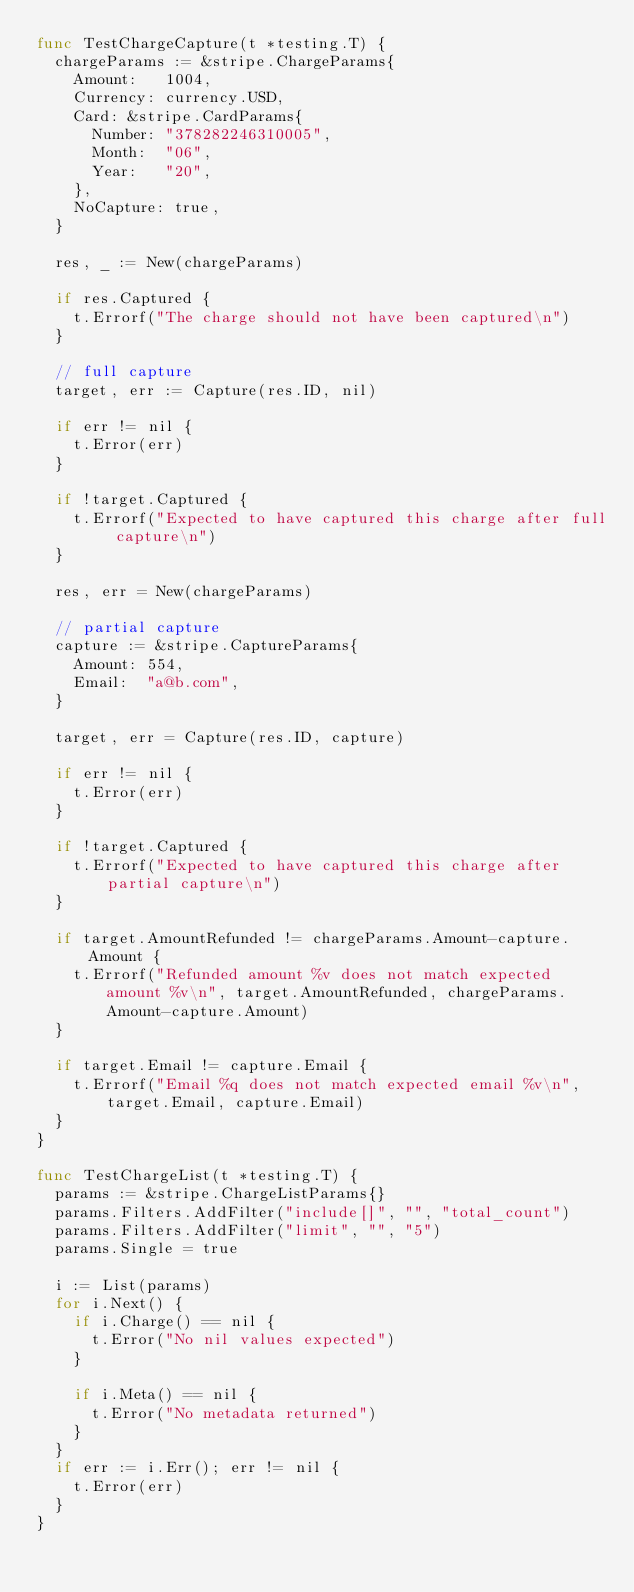<code> <loc_0><loc_0><loc_500><loc_500><_Go_>func TestChargeCapture(t *testing.T) {
	chargeParams := &stripe.ChargeParams{
		Amount:   1004,
		Currency: currency.USD,
		Card: &stripe.CardParams{
			Number: "378282246310005",
			Month:  "06",
			Year:   "20",
		},
		NoCapture: true,
	}

	res, _ := New(chargeParams)

	if res.Captured {
		t.Errorf("The charge should not have been captured\n")
	}

	// full capture
	target, err := Capture(res.ID, nil)

	if err != nil {
		t.Error(err)
	}

	if !target.Captured {
		t.Errorf("Expected to have captured this charge after full capture\n")
	}

	res, err = New(chargeParams)

	// partial capture
	capture := &stripe.CaptureParams{
		Amount: 554,
		Email:  "a@b.com",
	}

	target, err = Capture(res.ID, capture)

	if err != nil {
		t.Error(err)
	}

	if !target.Captured {
		t.Errorf("Expected to have captured this charge after partial capture\n")
	}

	if target.AmountRefunded != chargeParams.Amount-capture.Amount {
		t.Errorf("Refunded amount %v does not match expected amount %v\n", target.AmountRefunded, chargeParams.Amount-capture.Amount)
	}

	if target.Email != capture.Email {
		t.Errorf("Email %q does not match expected email %v\n", target.Email, capture.Email)
	}
}

func TestChargeList(t *testing.T) {
	params := &stripe.ChargeListParams{}
	params.Filters.AddFilter("include[]", "", "total_count")
	params.Filters.AddFilter("limit", "", "5")
	params.Single = true

	i := List(params)
	for i.Next() {
		if i.Charge() == nil {
			t.Error("No nil values expected")
		}

		if i.Meta() == nil {
			t.Error("No metadata returned")
		}
	}
	if err := i.Err(); err != nil {
		t.Error(err)
	}
}
</code> 